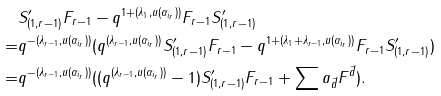Convert formula to latex. <formula><loc_0><loc_0><loc_500><loc_500>& S ^ { \prime } _ { ( 1 , r - 1 ) } F _ { r - 1 } - q ^ { 1 + ( \lambda _ { 1 } , u ( \alpha _ { i _ { r } } ) ) } F _ { r - 1 } S ^ { \prime } _ { ( 1 , r - 1 ) } \\ = & q ^ { - ( \lambda _ { r - 1 } , u ( \alpha _ { i _ { r } } ) ) } ( q ^ { ( \lambda _ { r - 1 } , u ( \alpha _ { i _ { r } } ) ) } S ^ { \prime } _ { ( 1 , r - 1 ) } F _ { r - 1 } - q ^ { 1 + ( \lambda _ { 1 } + \lambda _ { r - 1 } , u ( \alpha _ { i _ { r } } ) ) } F _ { r - 1 } S ^ { \prime } _ { ( 1 , r - 1 ) } ) \\ = & q ^ { - ( \lambda _ { r - 1 } , u ( \alpha _ { i _ { r } } ) ) } ( ( q ^ { ( \lambda _ { r - 1 } , u ( \alpha _ { i _ { r } } ) ) } - 1 ) S ^ { \prime } _ { ( 1 , r - 1 ) } F _ { r - 1 } + \sum a _ { \vec { d } } F ^ { \vec { d } } ) .</formula> 